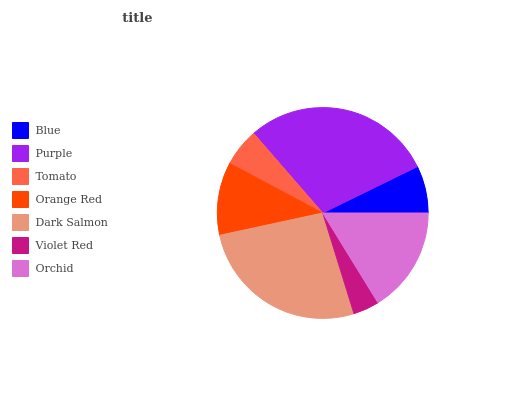Is Violet Red the minimum?
Answer yes or no. Yes. Is Purple the maximum?
Answer yes or no. Yes. Is Tomato the minimum?
Answer yes or no. No. Is Tomato the maximum?
Answer yes or no. No. Is Purple greater than Tomato?
Answer yes or no. Yes. Is Tomato less than Purple?
Answer yes or no. Yes. Is Tomato greater than Purple?
Answer yes or no. No. Is Purple less than Tomato?
Answer yes or no. No. Is Orange Red the high median?
Answer yes or no. Yes. Is Orange Red the low median?
Answer yes or no. Yes. Is Orchid the high median?
Answer yes or no. No. Is Violet Red the low median?
Answer yes or no. No. 